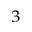<formula> <loc_0><loc_0><loc_500><loc_500>^ { 3 }</formula> 